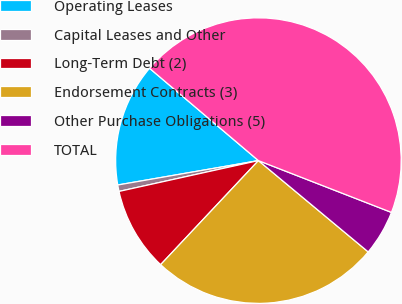<chart> <loc_0><loc_0><loc_500><loc_500><pie_chart><fcel>Operating Leases<fcel>Capital Leases and Other<fcel>Long-Term Debt (2)<fcel>Endorsement Contracts (3)<fcel>Other Purchase Obligations (5)<fcel>TOTAL<nl><fcel>13.93%<fcel>0.73%<fcel>9.53%<fcel>25.97%<fcel>5.13%<fcel>44.72%<nl></chart> 